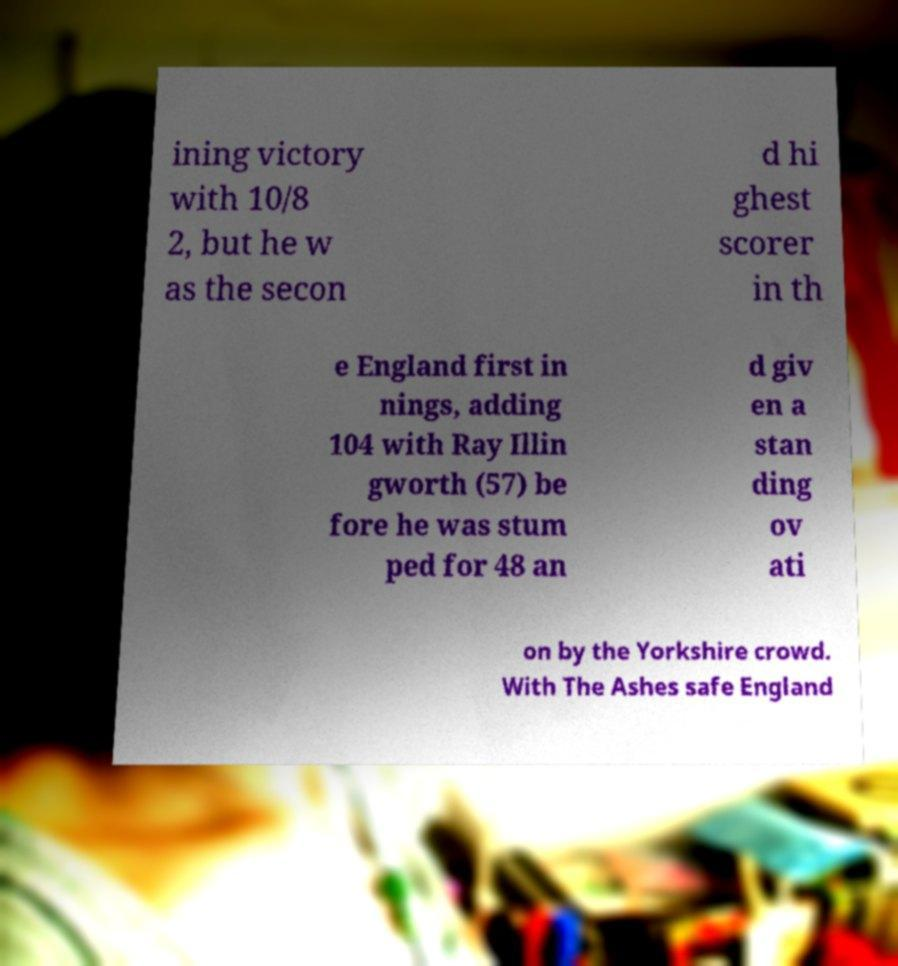Please read and relay the text visible in this image. What does it say? ining victory with 10/8 2, but he w as the secon d hi ghest scorer in th e England first in nings, adding 104 with Ray Illin gworth (57) be fore he was stum ped for 48 an d giv en a stan ding ov ati on by the Yorkshire crowd. With The Ashes safe England 